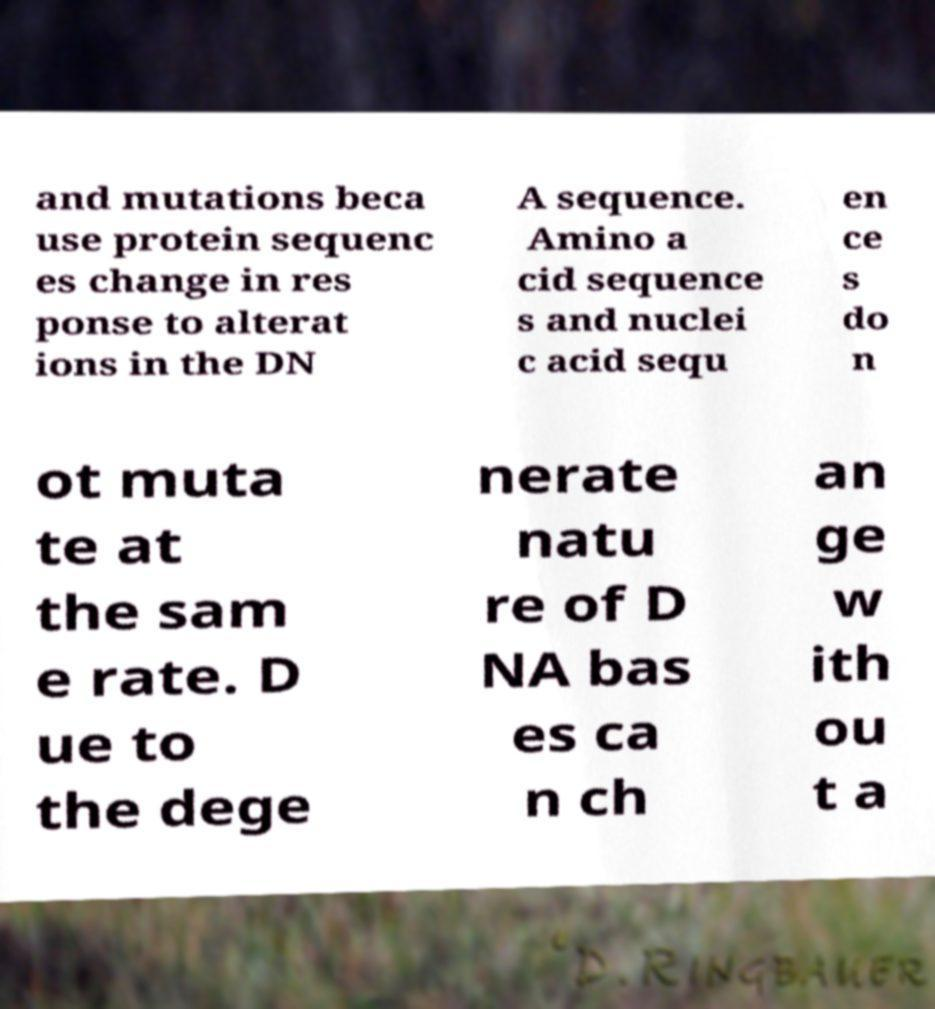Please identify and transcribe the text found in this image. and mutations beca use protein sequenc es change in res ponse to alterat ions in the DN A sequence. Amino a cid sequence s and nuclei c acid sequ en ce s do n ot muta te at the sam e rate. D ue to the dege nerate natu re of D NA bas es ca n ch an ge w ith ou t a 